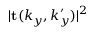<formula> <loc_0><loc_0><loc_500><loc_500>| t ( k _ { y } , k _ { y } ^ { \prime } ) | ^ { 2 }</formula> 